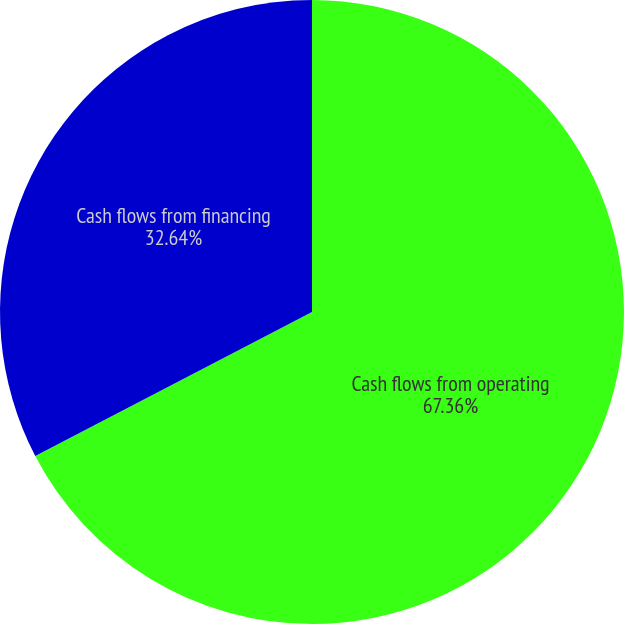<chart> <loc_0><loc_0><loc_500><loc_500><pie_chart><fcel>Cash flows from operating<fcel>Cash flows from financing<nl><fcel>67.36%<fcel>32.64%<nl></chart> 